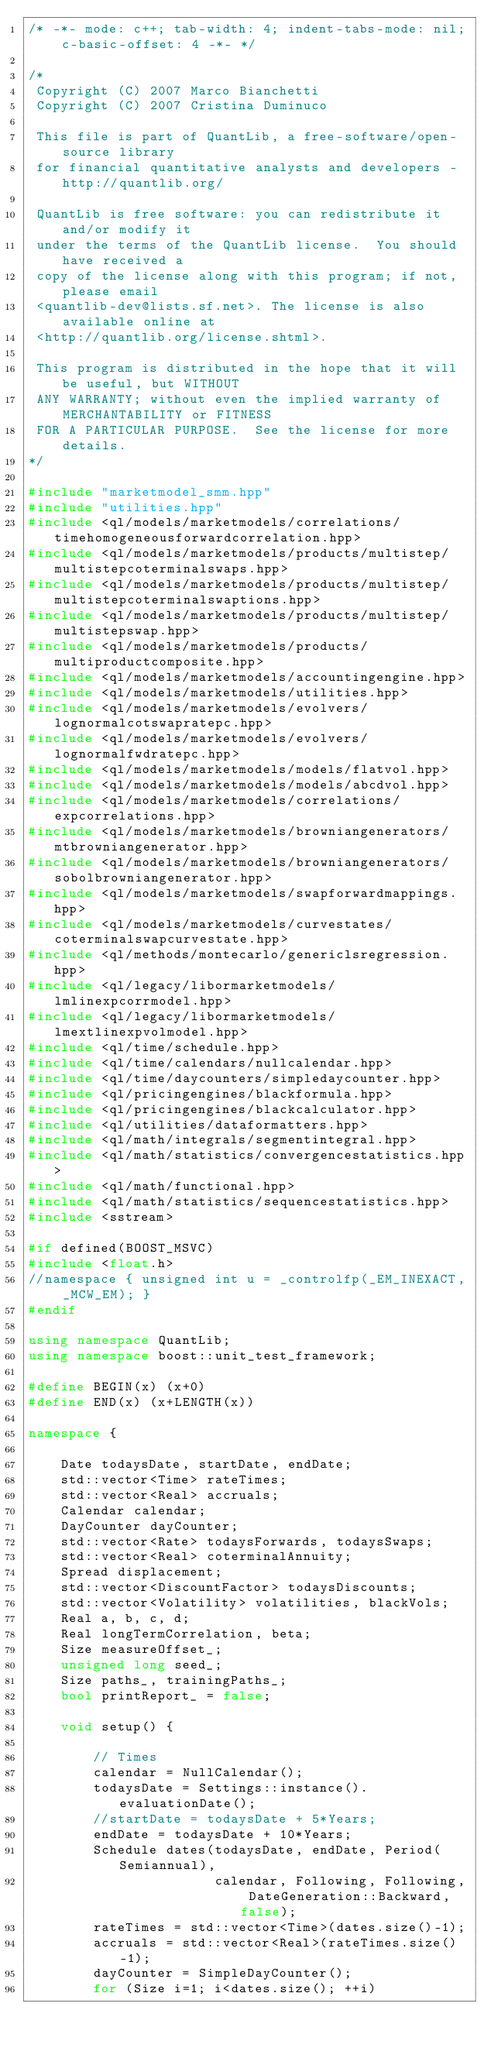<code> <loc_0><loc_0><loc_500><loc_500><_C++_>/* -*- mode: c++; tab-width: 4; indent-tabs-mode: nil; c-basic-offset: 4 -*- */

/*
 Copyright (C) 2007 Marco Bianchetti
 Copyright (C) 2007 Cristina Duminuco

 This file is part of QuantLib, a free-software/open-source library
 for financial quantitative analysts and developers - http://quantlib.org/

 QuantLib is free software: you can redistribute it and/or modify it
 under the terms of the QuantLib license.  You should have received a
 copy of the license along with this program; if not, please email
 <quantlib-dev@lists.sf.net>. The license is also available online at
 <http://quantlib.org/license.shtml>.

 This program is distributed in the hope that it will be useful, but WITHOUT
 ANY WARRANTY; without even the implied warranty of MERCHANTABILITY or FITNESS
 FOR A PARTICULAR PURPOSE.  See the license for more details.
*/

#include "marketmodel_smm.hpp"
#include "utilities.hpp"
#include <ql/models/marketmodels/correlations/timehomogeneousforwardcorrelation.hpp>
#include <ql/models/marketmodels/products/multistep/multistepcoterminalswaps.hpp>
#include <ql/models/marketmodels/products/multistep/multistepcoterminalswaptions.hpp>
#include <ql/models/marketmodels/products/multistep/multistepswap.hpp>
#include <ql/models/marketmodels/products/multiproductcomposite.hpp>
#include <ql/models/marketmodels/accountingengine.hpp>
#include <ql/models/marketmodels/utilities.hpp>
#include <ql/models/marketmodels/evolvers/lognormalcotswapratepc.hpp>
#include <ql/models/marketmodels/evolvers/lognormalfwdratepc.hpp>
#include <ql/models/marketmodels/models/flatvol.hpp>
#include <ql/models/marketmodels/models/abcdvol.hpp>
#include <ql/models/marketmodels/correlations/expcorrelations.hpp>
#include <ql/models/marketmodels/browniangenerators/mtbrowniangenerator.hpp>
#include <ql/models/marketmodels/browniangenerators/sobolbrowniangenerator.hpp>
#include <ql/models/marketmodels/swapforwardmappings.hpp>
#include <ql/models/marketmodels/curvestates/coterminalswapcurvestate.hpp>
#include <ql/methods/montecarlo/genericlsregression.hpp>
#include <ql/legacy/libormarketmodels/lmlinexpcorrmodel.hpp>
#include <ql/legacy/libormarketmodels/lmextlinexpvolmodel.hpp>
#include <ql/time/schedule.hpp>
#include <ql/time/calendars/nullcalendar.hpp>
#include <ql/time/daycounters/simpledaycounter.hpp>
#include <ql/pricingengines/blackformula.hpp>
#include <ql/pricingengines/blackcalculator.hpp>
#include <ql/utilities/dataformatters.hpp>
#include <ql/math/integrals/segmentintegral.hpp>
#include <ql/math/statistics/convergencestatistics.hpp>
#include <ql/math/functional.hpp>
#include <ql/math/statistics/sequencestatistics.hpp>
#include <sstream>

#if defined(BOOST_MSVC)
#include <float.h>
//namespace { unsigned int u = _controlfp(_EM_INEXACT, _MCW_EM); }
#endif

using namespace QuantLib;
using namespace boost::unit_test_framework;

#define BEGIN(x) (x+0)
#define END(x) (x+LENGTH(x))

namespace {

    Date todaysDate, startDate, endDate;
    std::vector<Time> rateTimes;
    std::vector<Real> accruals;
    Calendar calendar;
    DayCounter dayCounter;
    std::vector<Rate> todaysForwards, todaysSwaps;
    std::vector<Real> coterminalAnnuity;
    Spread displacement;
    std::vector<DiscountFactor> todaysDiscounts;
    std::vector<Volatility> volatilities, blackVols;
    Real a, b, c, d;
    Real longTermCorrelation, beta;
    Size measureOffset_;
    unsigned long seed_;
    Size paths_, trainingPaths_;
    bool printReport_ = false;

    void setup() {

        // Times
        calendar = NullCalendar();
        todaysDate = Settings::instance().evaluationDate();
        //startDate = todaysDate + 5*Years;
        endDate = todaysDate + 10*Years;
        Schedule dates(todaysDate, endDate, Period(Semiannual),
                       calendar, Following, Following, DateGeneration::Backward, false);
        rateTimes = std::vector<Time>(dates.size()-1);
        accruals = std::vector<Real>(rateTimes.size()-1);
        dayCounter = SimpleDayCounter();
        for (Size i=1; i<dates.size(); ++i)</code> 